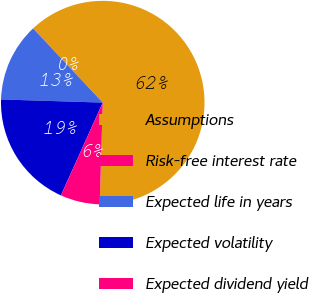<chart> <loc_0><loc_0><loc_500><loc_500><pie_chart><fcel>Assumptions<fcel>Risk-free interest rate<fcel>Expected life in years<fcel>Expected volatility<fcel>Expected dividend yield<nl><fcel>62.46%<fcel>0.02%<fcel>12.51%<fcel>18.75%<fcel>6.26%<nl></chart> 